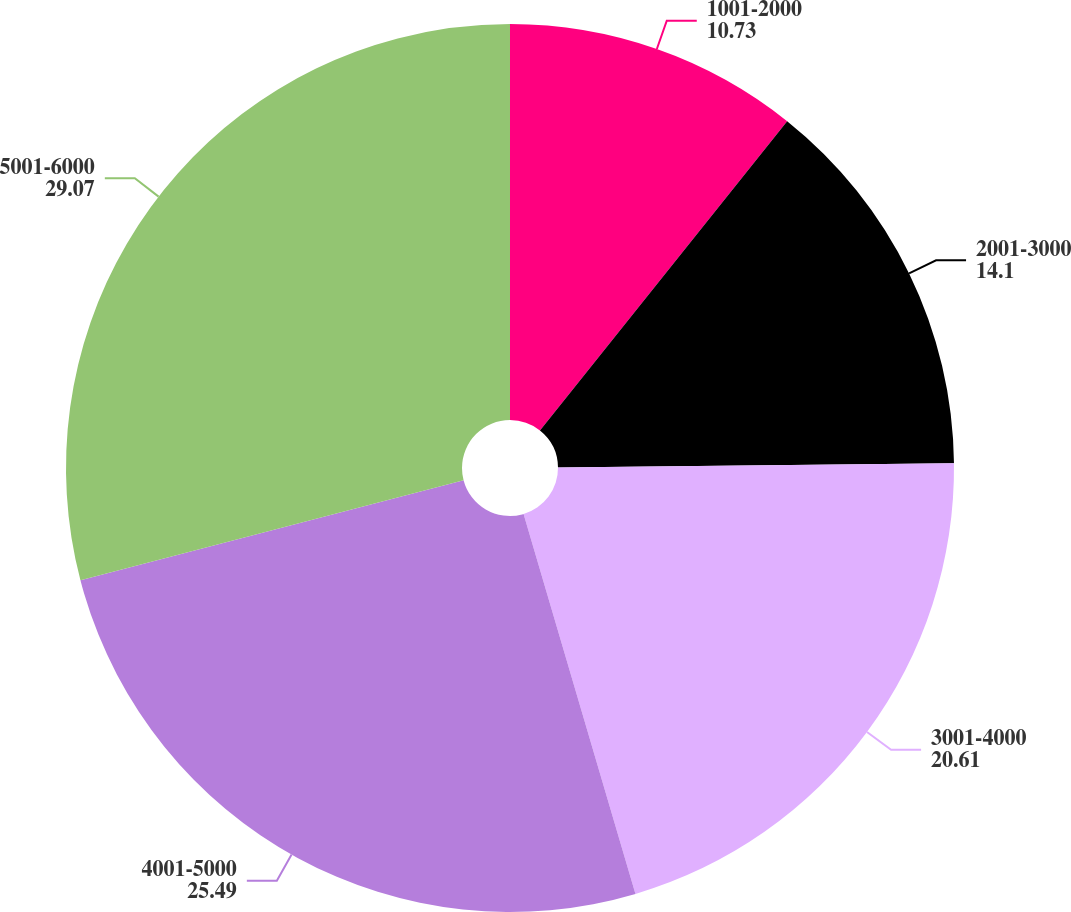Convert chart to OTSL. <chart><loc_0><loc_0><loc_500><loc_500><pie_chart><fcel>1001-2000<fcel>2001-3000<fcel>3001-4000<fcel>4001-5000<fcel>5001-6000<nl><fcel>10.73%<fcel>14.1%<fcel>20.61%<fcel>25.49%<fcel>29.07%<nl></chart> 